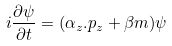Convert formula to latex. <formula><loc_0><loc_0><loc_500><loc_500>i \frac { \partial \psi } { \partial t } = ( \alpha _ { z } . p _ { z } + \beta m ) \psi</formula> 